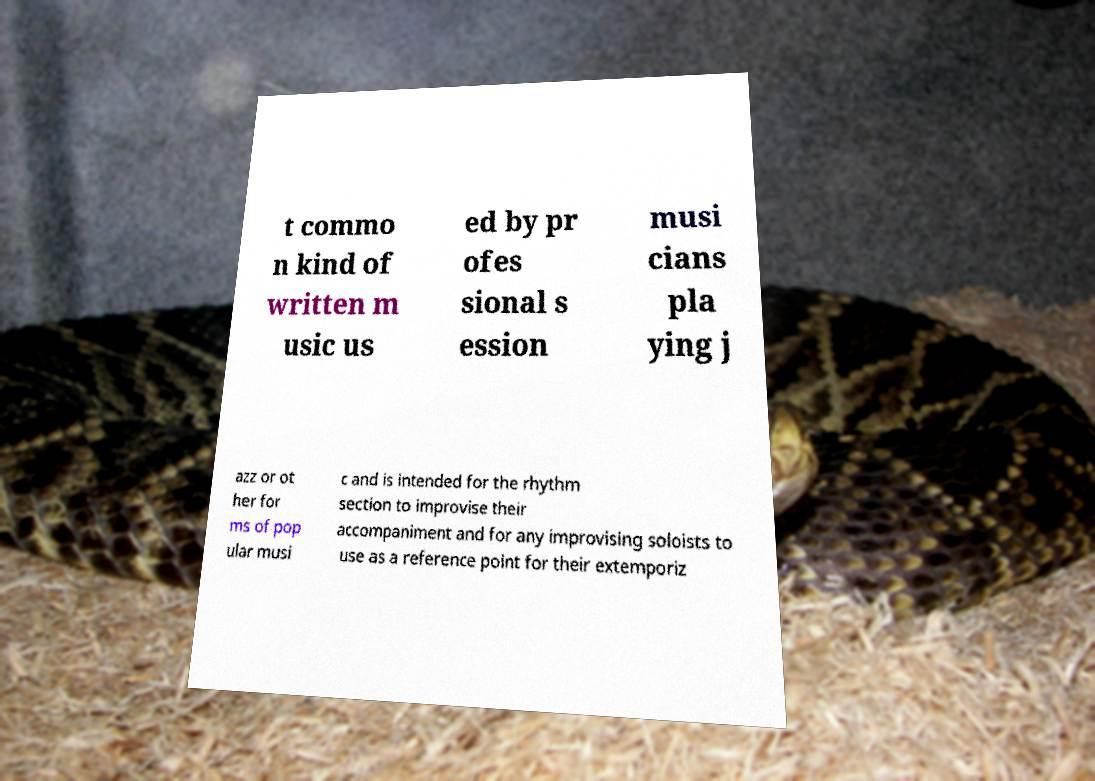Can you accurately transcribe the text from the provided image for me? t commo n kind of written m usic us ed by pr ofes sional s ession musi cians pla ying j azz or ot her for ms of pop ular musi c and is intended for the rhythm section to improvise their accompaniment and for any improvising soloists to use as a reference point for their extemporiz 